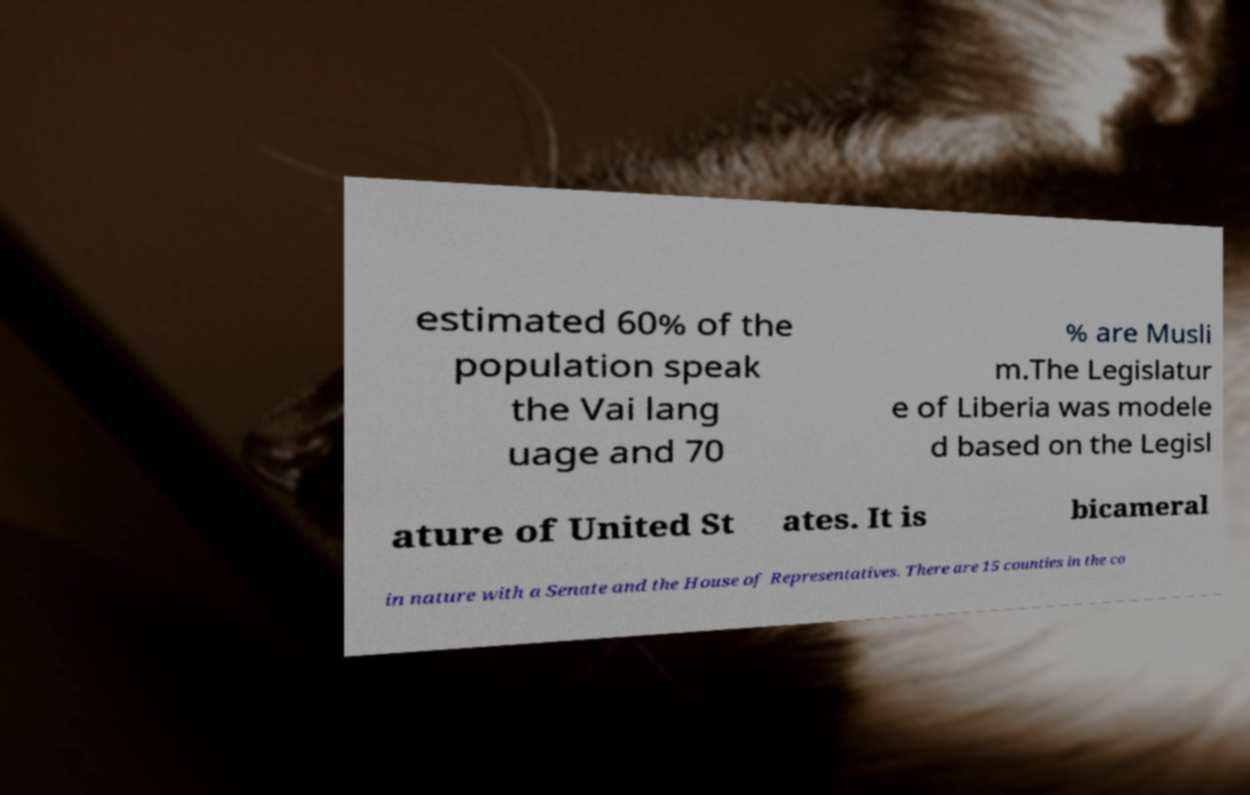Please read and relay the text visible in this image. What does it say? estimated 60% of the population speak the Vai lang uage and 70 % are Musli m.The Legislatur e of Liberia was modele d based on the Legisl ature of United St ates. It is bicameral in nature with a Senate and the House of Representatives. There are 15 counties in the co 